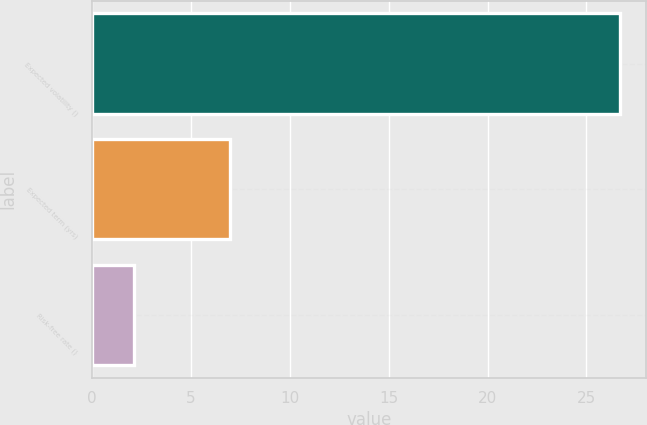Convert chart. <chart><loc_0><loc_0><loc_500><loc_500><bar_chart><fcel>Expected volatility ()<fcel>Expected term (yrs)<fcel>Risk-free rate ()<nl><fcel>26.7<fcel>7<fcel>2.1<nl></chart> 